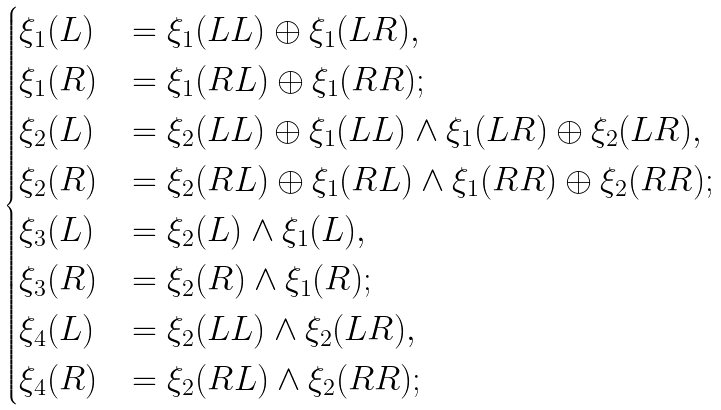Convert formula to latex. <formula><loc_0><loc_0><loc_500><loc_500>\begin{cases} \xi _ { 1 } ( L ) & = \xi _ { 1 } ( L L ) \oplus \xi _ { 1 } ( L R ) , \\ \xi _ { 1 } ( R ) & = \xi _ { 1 } ( R L ) \oplus \xi _ { 1 } ( R R ) ; \\ \xi _ { 2 } ( L ) & = \xi _ { 2 } ( L L ) \oplus \xi _ { 1 } ( L L ) \wedge \xi _ { 1 } ( L R ) \oplus \xi _ { 2 } ( L R ) , \\ \xi _ { 2 } ( R ) & = \xi _ { 2 } ( R L ) \oplus \xi _ { 1 } ( R L ) \wedge \xi _ { 1 } ( R R ) \oplus \xi _ { 2 } ( R R ) ; \\ \xi _ { 3 } ( L ) & = \xi _ { 2 } ( L ) \wedge \xi _ { 1 } ( L ) , \\ \xi _ { 3 } ( R ) & = \xi _ { 2 } ( R ) \wedge \xi _ { 1 } ( R ) ; \\ \xi _ { 4 } ( L ) & = \xi _ { 2 } ( L L ) \wedge \xi _ { 2 } ( L R ) , \\ \xi _ { 4 } ( R ) & = \xi _ { 2 } ( R L ) \wedge \xi _ { 2 } ( R R ) ; \\ \end{cases}</formula> 